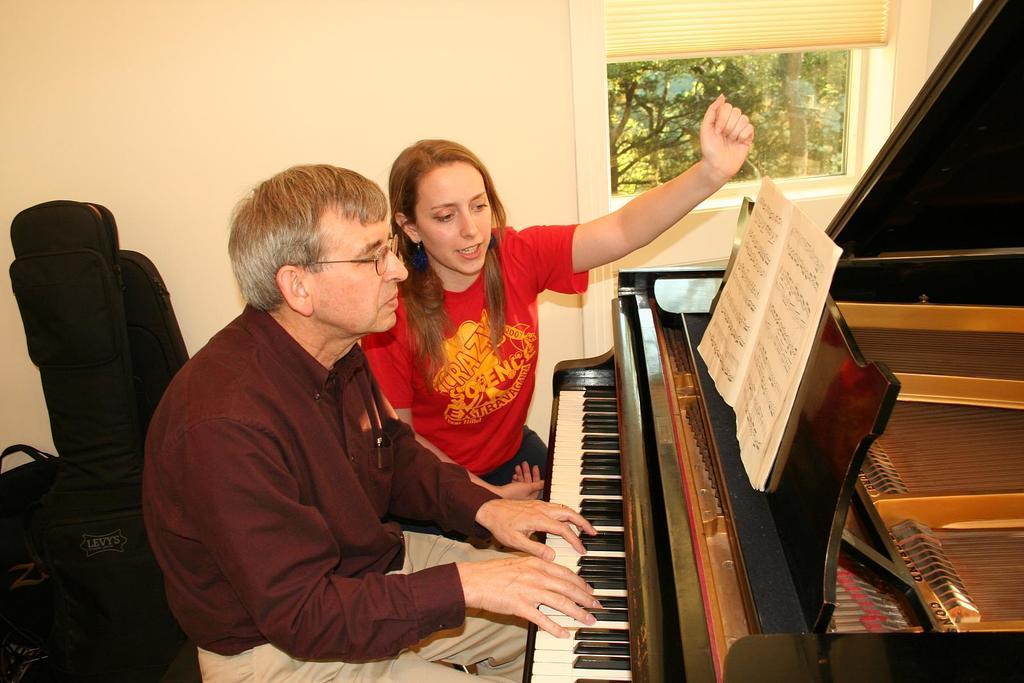Please provide a concise description of this image. This picture is taken inside a room. There are two people in the room. The man in the image is playing piano looking at the musical notes in the book. The woman beside him is wearing a red dress and singing. There are bags behind them. In the background there is wall, window and window blinds. Through the window trees are seen.  